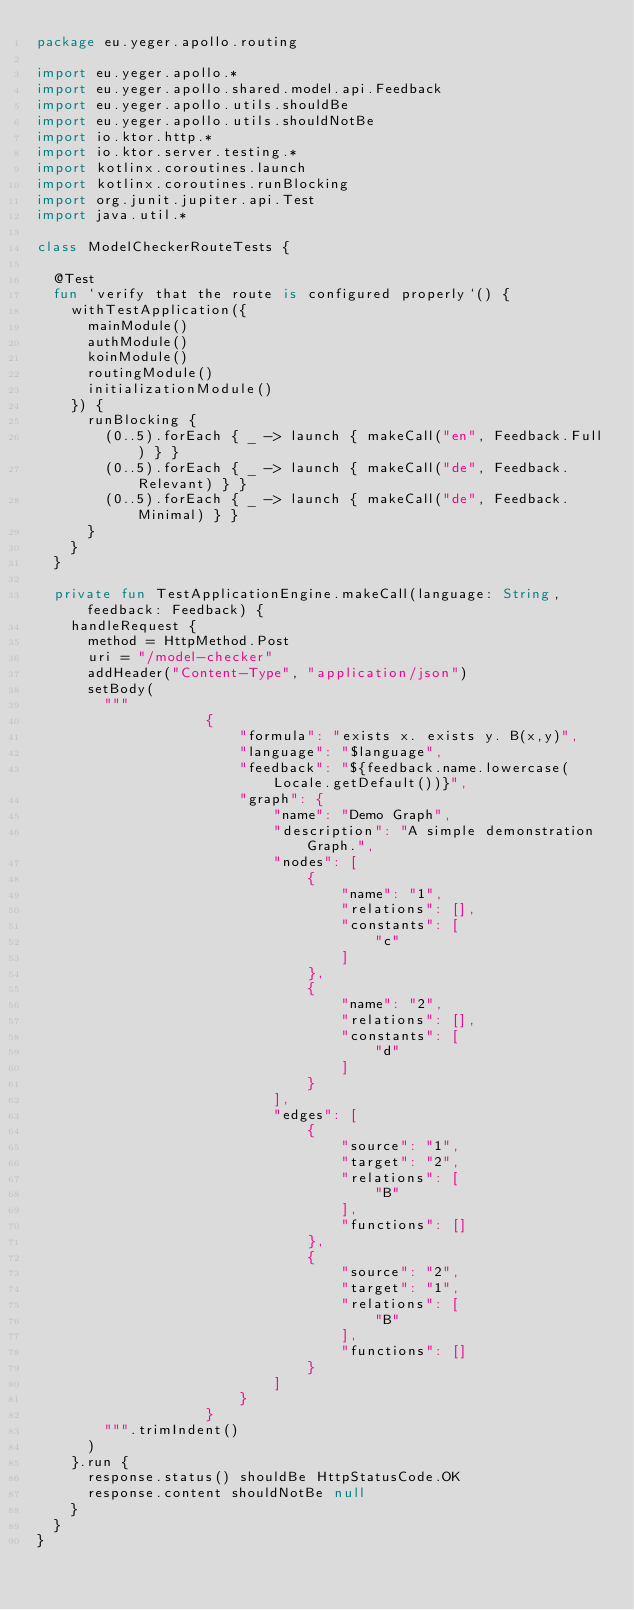<code> <loc_0><loc_0><loc_500><loc_500><_Kotlin_>package eu.yeger.apollo.routing

import eu.yeger.apollo.*
import eu.yeger.apollo.shared.model.api.Feedback
import eu.yeger.apollo.utils.shouldBe
import eu.yeger.apollo.utils.shouldNotBe
import io.ktor.http.*
import io.ktor.server.testing.*
import kotlinx.coroutines.launch
import kotlinx.coroutines.runBlocking
import org.junit.jupiter.api.Test
import java.util.*

class ModelCheckerRouteTests {

  @Test
  fun `verify that the route is configured properly`() {
    withTestApplication({
      mainModule()
      authModule()
      koinModule()
      routingModule()
      initializationModule()
    }) {
      runBlocking {
        (0..5).forEach { _ -> launch { makeCall("en", Feedback.Full) } }
        (0..5).forEach { _ -> launch { makeCall("de", Feedback.Relevant) } }
        (0..5).forEach { _ -> launch { makeCall("de", Feedback.Minimal) } }
      }
    }
  }

  private fun TestApplicationEngine.makeCall(language: String, feedback: Feedback) {
    handleRequest {
      method = HttpMethod.Post
      uri = "/model-checker"
      addHeader("Content-Type", "application/json")
      setBody(
        """
                    {
                        "formula": "exists x. exists y. B(x,y)",
                        "language": "$language",
                        "feedback": "${feedback.name.lowercase(Locale.getDefault())}",
                        "graph": {
                            "name": "Demo Graph",
                            "description": "A simple demonstration Graph.",
                            "nodes": [
                                {
                                    "name": "1",
                                    "relations": [],
                                    "constants": [
                                        "c"
                                    ]
                                },
                                {
                                    "name": "2",
                                    "relations": [],
                                    "constants": [
                                        "d"
                                    ]
                                }
                            ],
                            "edges": [
                                {
                                    "source": "1",
                                    "target": "2",
                                    "relations": [
                                        "B"
                                    ],
                                    "functions": []
                                },
                                {
                                    "source": "2",
                                    "target": "1",
                                    "relations": [
                                        "B"
                                    ],
                                    "functions": []
                                }
                            ]
                        }
                    }
        """.trimIndent()
      )
    }.run {
      response.status() shouldBe HttpStatusCode.OK
      response.content shouldNotBe null
    }
  }
}
</code> 